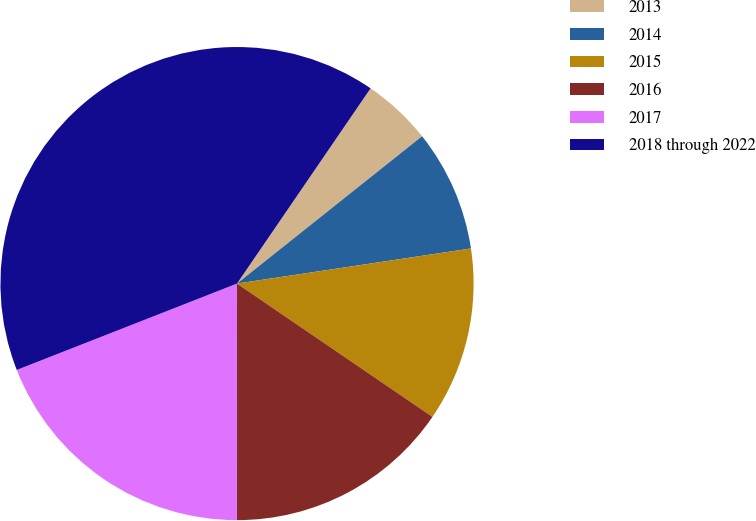Convert chart. <chart><loc_0><loc_0><loc_500><loc_500><pie_chart><fcel>2013<fcel>2014<fcel>2015<fcel>2016<fcel>2017<fcel>2018 through 2022<nl><fcel>4.75%<fcel>8.33%<fcel>11.9%<fcel>15.48%<fcel>19.05%<fcel>40.5%<nl></chart> 